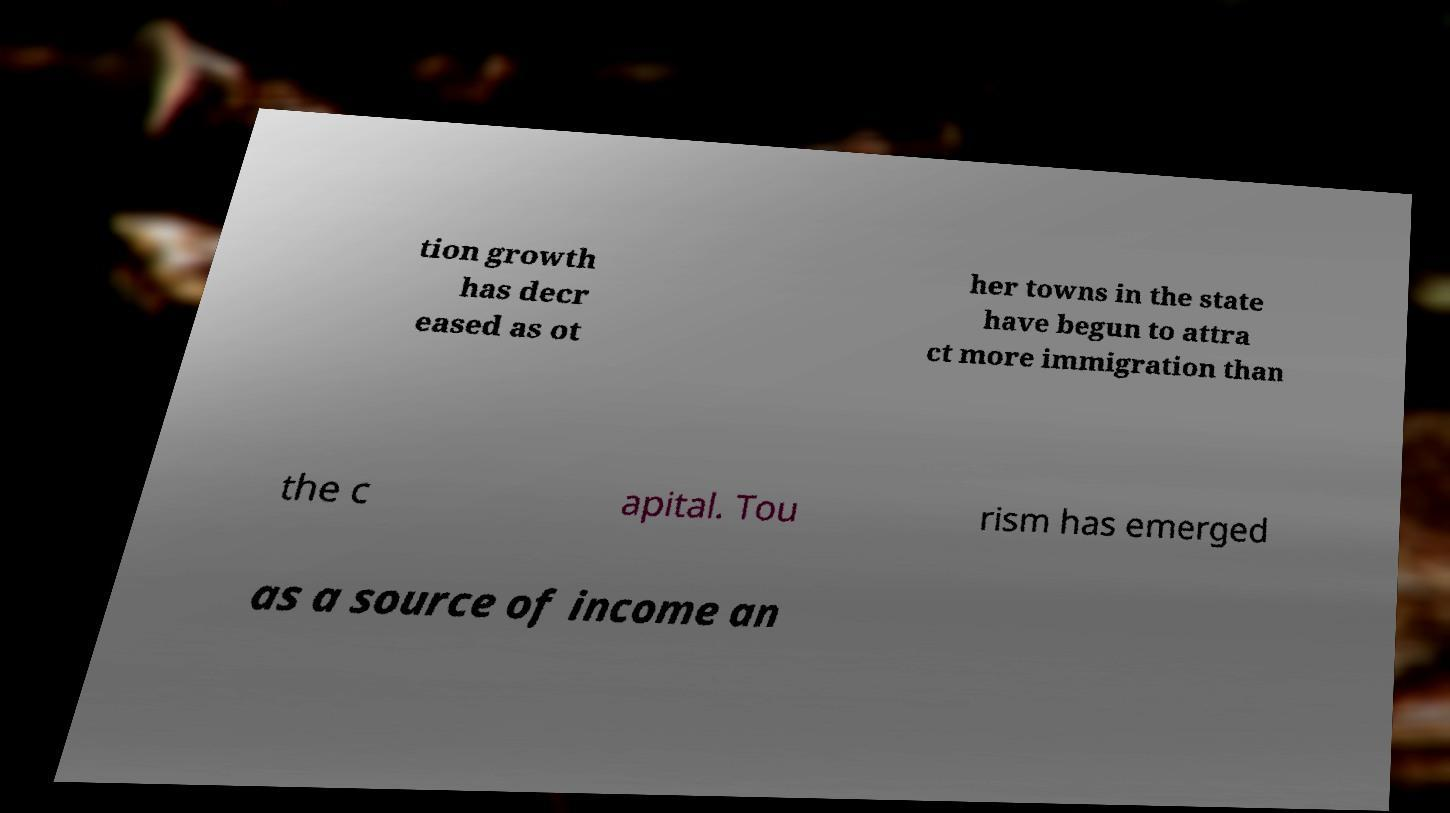Please identify and transcribe the text found in this image. tion growth has decr eased as ot her towns in the state have begun to attra ct more immigration than the c apital. Tou rism has emerged as a source of income an 